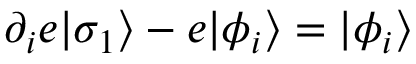Convert formula to latex. <formula><loc_0><loc_0><loc_500><loc_500>\partial _ { i } e | \sigma _ { 1 } \rangle - e | \phi _ { i } \rangle = | \phi _ { i } \rangle \,</formula> 